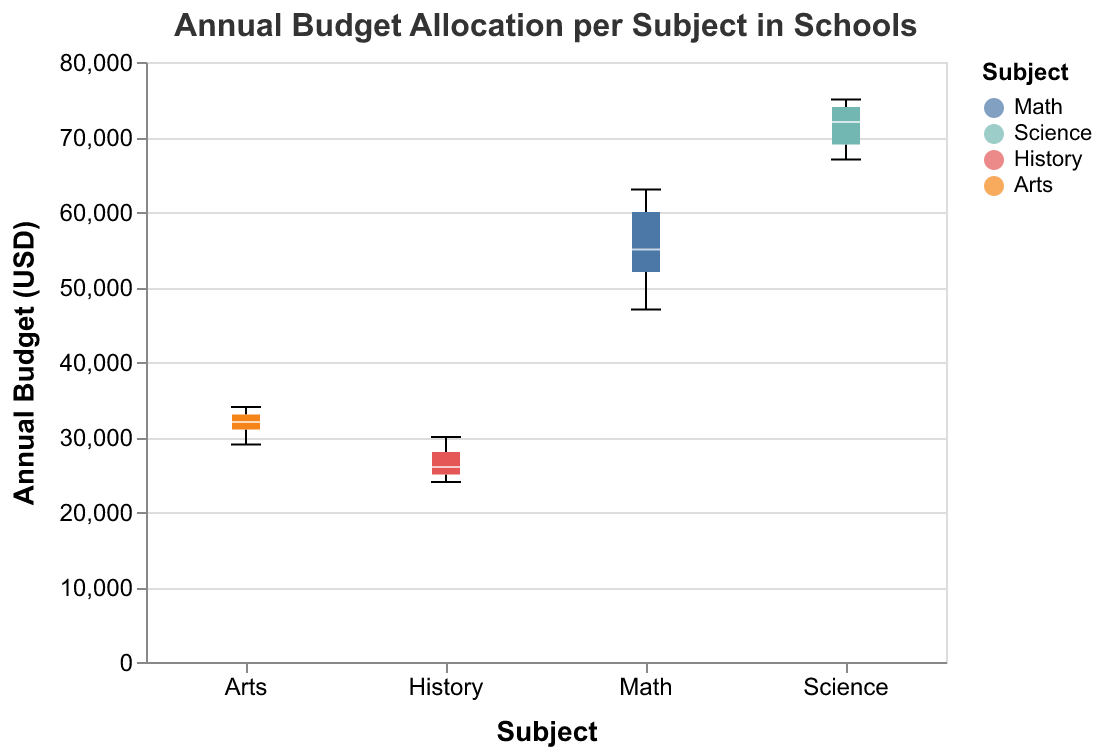What is the title of the figure? The title is usually found at the top of the figure and is specified by the "title" attribute in the code.
Answer: Annual Budget Allocation per Subject in Schools Which subject has the highest median budget allocation? The median value is shown within the boxplot, typically marked by a line inside the box.
Answer: Science What is the range of the annual budget allocation for the Math subject? The range is the difference between the highest and lowest values, indicated by the top and bottom of the whiskers in the box plot. For the Math subject, the highest value is 63000 and the lowest is 47000, so the range is 63000 - 47000.
Answer: 16000 Which subject has the lowest maximum annual budget allocation? The maximum value for each subject is indicated by the top of the respective whisker in the box plot. By comparing the tops of the whiskers, History has the lowest maximum value at 30000.
Answer: History How do the median values of the Math and Arts subjects compare? Observe the position of the median lines within the boxes for both subjects. Math's median value is lower than Arts' median value.
Answer: Math's median is lower than Arts' median What is the interquartile range (IQR) for the Science subject? The IQR is found by subtracting the lower quartile value from the upper quartile value. For Science, the lower quartile is around 67000 and the upper quartile is around 74000. Hence, the IQR is 74000 - 67000.
Answer: 7000 Which subject has the most variability in its budget allocation? Variability can be assessed by looking at the length of the boxes and whiskers. Science has the longest whiskers and box, indicating the most variability.
Answer: Science Compare the annual budget allocations of History and Arts – which has a higher median and which has more variability? The median is shown by the line inside the box plot; compare the medians of History and Arts to see that Arts has a higher median. Variability can be assessed by the length of the whiskers; History has shorter whiskers, indicating less variability than Arts.
Answer: Arts has a higher median and Arts has more variability 